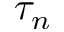Convert formula to latex. <formula><loc_0><loc_0><loc_500><loc_500>\tau _ { n }</formula> 